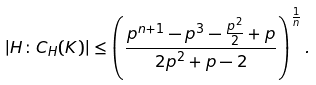Convert formula to latex. <formula><loc_0><loc_0><loc_500><loc_500>| H \colon C _ { H } ( K ) | \leq \left ( \frac { p ^ { n + 1 } - p ^ { 3 } - \frac { p ^ { 2 } } { 2 } + p } { 2 p ^ { 2 } + p - 2 } \right ) ^ { \frac { 1 } { n } } .</formula> 